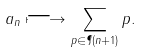<formula> <loc_0><loc_0><loc_500><loc_500>a _ { n } \longmapsto \sum _ { p \in \P ( n + 1 ) } p .</formula> 